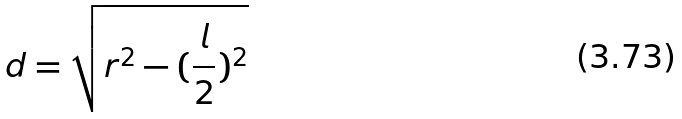Convert formula to latex. <formula><loc_0><loc_0><loc_500><loc_500>d = \sqrt { r ^ { 2 } - ( \frac { l } { 2 } ) ^ { 2 } }</formula> 